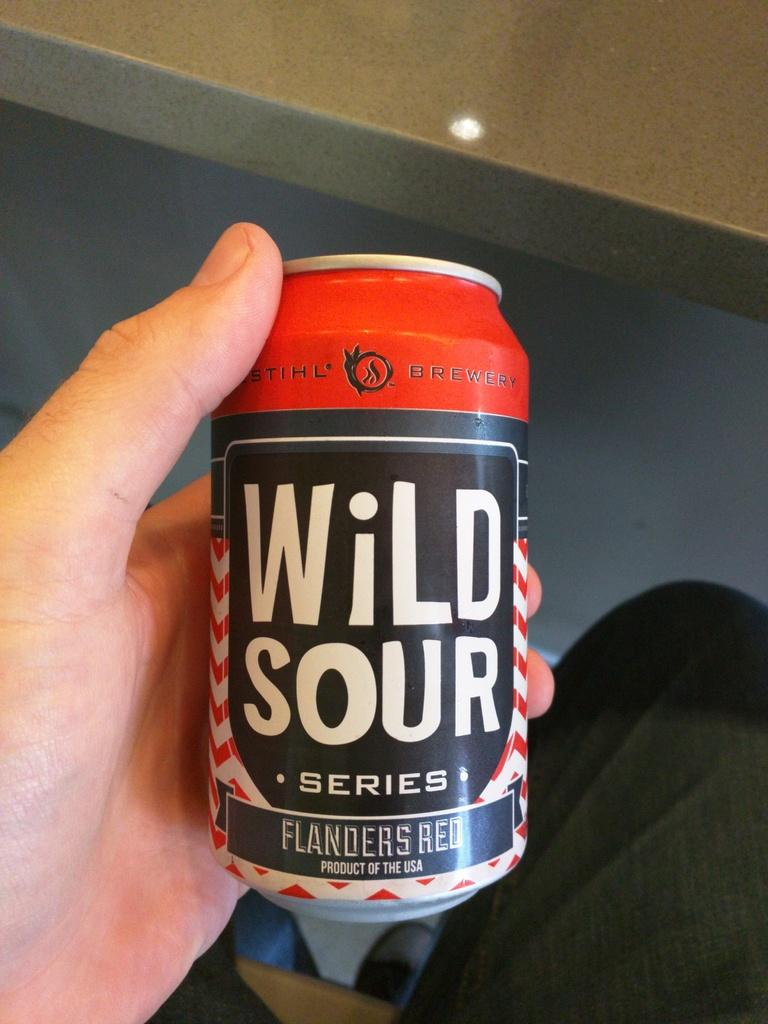<image>
Share a concise interpretation of the image provided. Person holding a beer can with the words Wild Sour on the front. 